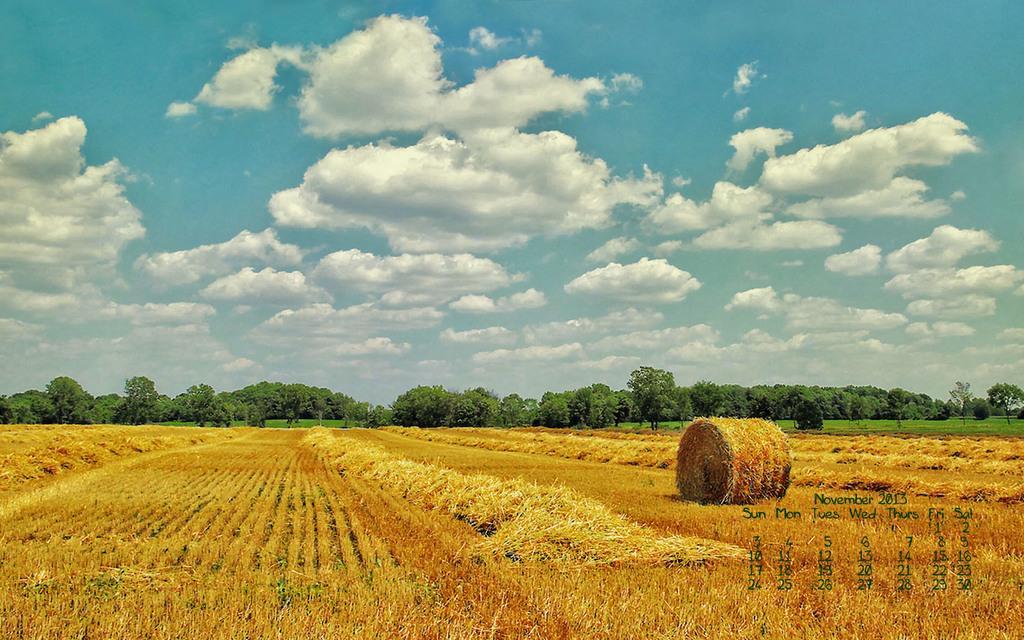Could you give a brief overview of what you see in this image? In this picture there are trees. At the top there is sky and there are clouds. At the bottom there is grass and there is a dried grass roll. On the right side of the image there is text and there are numbers. 